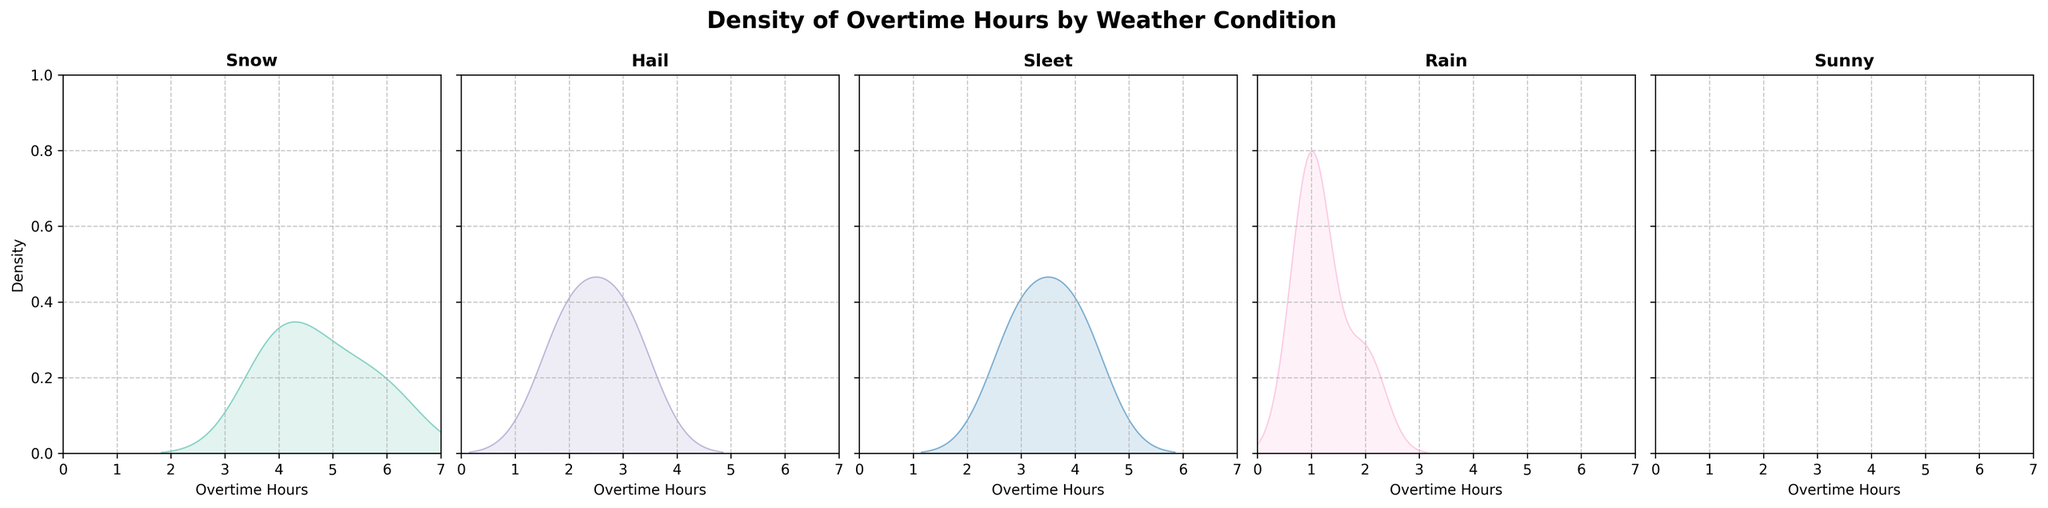What is the title of the figure? The title is usually located at the top of the figure and is meant to provide a summary of what the chart is about. In this figure, the title reads "Density of Overtime Hours by Weather Condition".
Answer: Density of Overtime Hours by Weather Condition Which weather condition shows the highest density of overtime hours? By examining the density plots, the highest density is represented by the peak of the curve. The Snow condition shows the highest peak, indicating the highest density of overtime hours.
Answer: Snow What is the range of overtime hours shown on each subplot? The range of the x-axis represents the overtime hours. From the figure, the x-axis for each subplot ranges from 0 to 7 hours.
Answer: 0 to 7 hours Which weather conditions show overtime hours with densities below 0.2? To find this, we look for the density plots that do not peak above the 0.2 mark on the y-axis. Both Rain and Sunny conditions have peaks below 0.2.
Answer: Rain, Sunny How does the density for "Rain" compare to "Hail"? Comparing the two density plots visually, Hail has a higher peak than Rain, which indicates a higher density of overtime hours worked during Hail than Rain.
Answer: Hail has higher density than Rain What is the general shape of the density plot for "Sunny" weather? The density plot for "Sunny" weather is quite flat and close to the x-axis, indicating that the density of overtime hours is low and spread out.
Answer: Flat and close to the x-axis Is there any overlap in the density plots of "Sleet" and "Hail"? Overlapping of density plots would be indicated by areas where the curves coincide. By closely observing, there seems to be slight overlap between Sleet and Hail around the lower overtime hours.
Answer: Yes, slight overlap for lower overtime hours What can be inferred about the variation in overtime hours during "Snow" conditions compared to "Sunny"? Observing the density plots, Snow shows a broad and high peak, indicating higher density and variability in overtime hours, while Sunny shows a much flatter curve, indicating lower variation and density.
Answer: Snow has higher variation compared to Sunny Among "Snow," "Rain," and "Hail," which condition shows the least amount of high overtime hours? The condition with the least density for higher overtime hours will have a flatter tail towards the end of x-axis. Rain has the flattest density towards higher hours, indicating less amount of high overtime hours.
Answer: Rain 